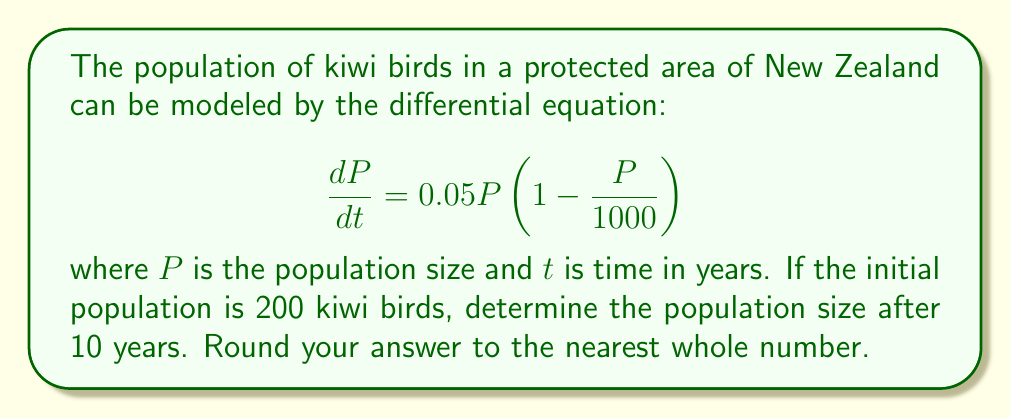Can you answer this question? To solve this problem, we need to recognize that this is a logistic growth model and use the appropriate solution method.

1) The general solution for a logistic growth model is:

   $$P(t) = \frac{K}{1 + \left(\frac{K}{P_0} - 1\right)e^{-rt}}$$

   where $K$ is the carrying capacity, $P_0$ is the initial population, and $r$ is the growth rate.

2) From the given equation, we can identify:
   $r = 0.05$ (growth rate)
   $K = 1000$ (carrying capacity)
   $P_0 = 200$ (initial population)

3) Substituting these values into the general solution:

   $$P(t) = \frac{1000}{1 + \left(\frac{1000}{200} - 1\right)e^{-0.05t}}$$

4) Simplify:

   $$P(t) = \frac{1000}{1 + 4e^{-0.05t}}$$

5) We want to find $P(10)$, so substitute $t = 10$:

   $$P(10) = \frac{1000}{1 + 4e^{-0.5}}$$

6) Calculate:
   $e^{-0.5} \approx 0.6065$
   $4e^{-0.5} \approx 2.4260$
   $1 + 4e^{-0.5} \approx 3.4260$

   $$P(10) = \frac{1000}{3.4260} \approx 291.8857$$

7) Rounding to the nearest whole number: 292
Answer: 292 kiwi birds 